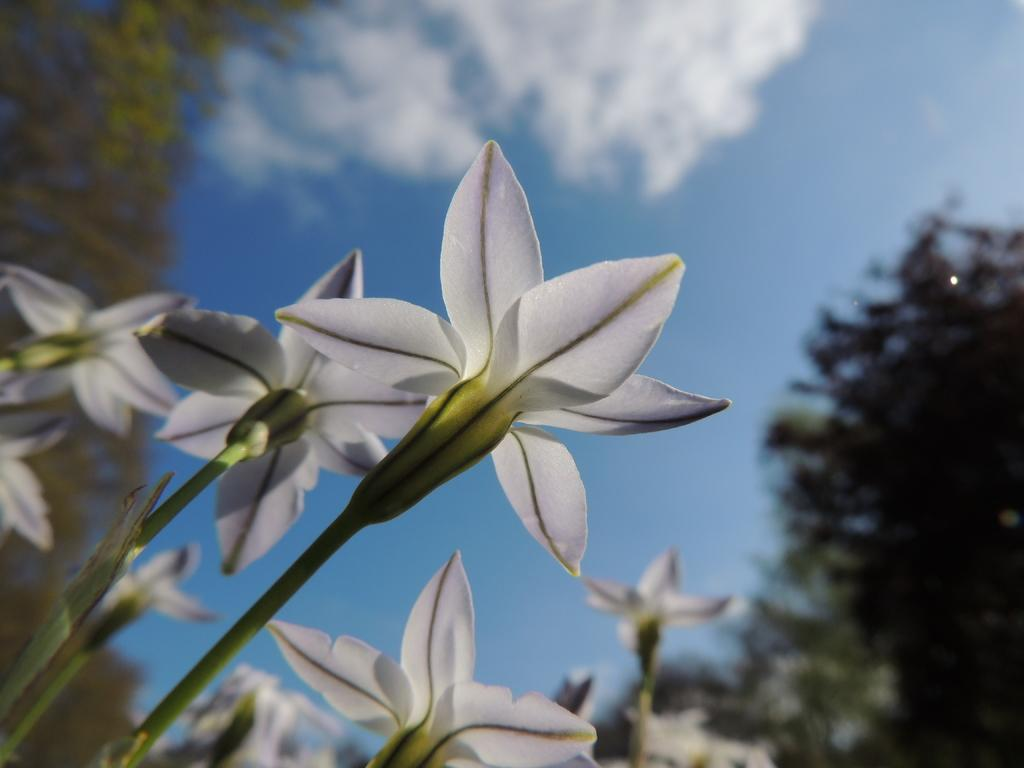What type of plants are on the left side of the image? There are plants with white flowers on the left side of the image. What can be seen in the background of the image? There are trees in the background of the image. How would you describe the sky in the image? The sky is blue and has clouds in it. Where is the kitten playing with the brain in the image? There is no kitten or brain present in the image. 